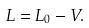<formula> <loc_0><loc_0><loc_500><loc_500>L = L _ { 0 } - V .</formula> 